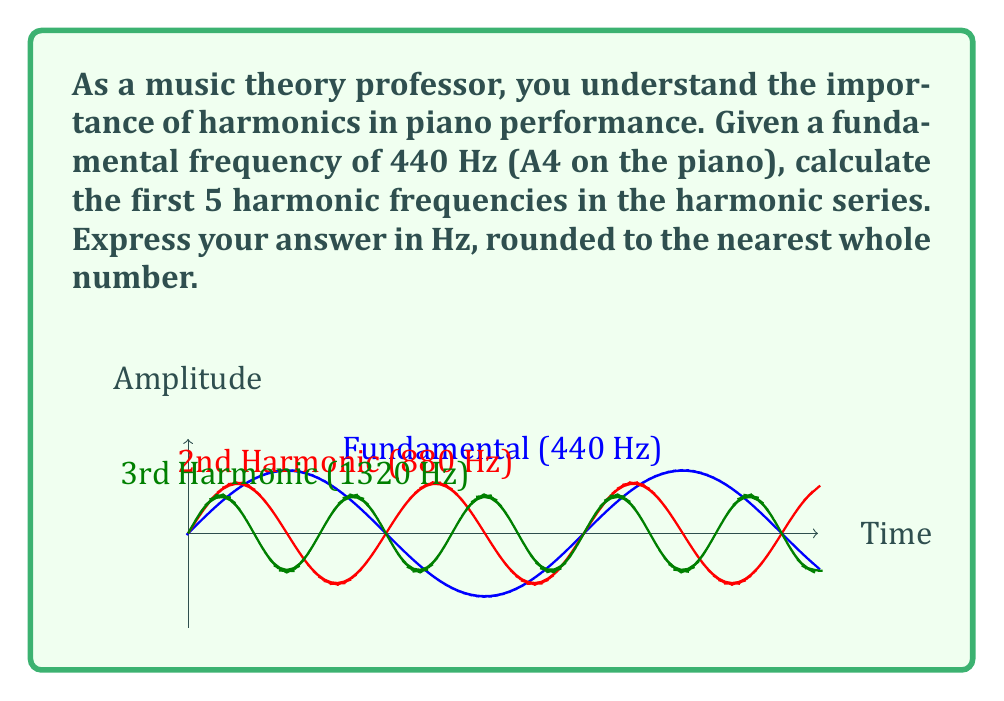Could you help me with this problem? To calculate the harmonic series, we use the formula:

$$f_n = n \cdot f_1$$

Where:
$f_n$ is the frequency of the nth harmonic
$n$ is the harmonic number
$f_1$ is the fundamental frequency

Given $f_1 = 440$ Hz, we calculate:

1. First harmonic (fundamental): $f_1 = 1 \cdot 440 = 440$ Hz
2. Second harmonic: $f_2 = 2 \cdot 440 = 880$ Hz
3. Third harmonic: $f_3 = 3 \cdot 440 = 1320$ Hz
4. Fourth harmonic: $f_4 = 4 \cdot 440 = 1760$ Hz
5. Fifth harmonic: $f_5 = 5 \cdot 440 = 2200$ Hz

Rounding to the nearest whole number is not necessary in this case as all results are already whole numbers.
Answer: 440 Hz, 880 Hz, 1320 Hz, 1760 Hz, 2200 Hz 